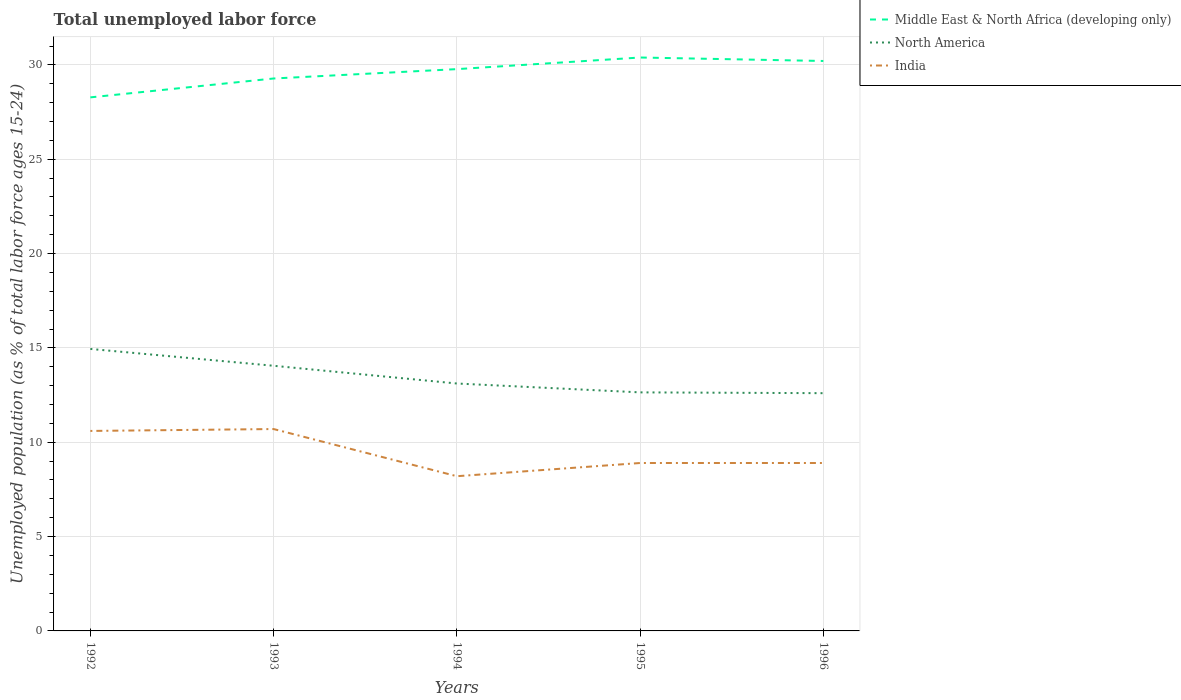Is the number of lines equal to the number of legend labels?
Your answer should be very brief. Yes. Across all years, what is the maximum percentage of unemployed population in in Middle East & North Africa (developing only)?
Ensure brevity in your answer.  28.28. What is the total percentage of unemployed population in in Middle East & North Africa (developing only) in the graph?
Offer a very short reply. -1.5. What is the difference between the highest and the second highest percentage of unemployed population in in Middle East & North Africa (developing only)?
Offer a terse response. 2.11. How many lines are there?
Offer a terse response. 3. How are the legend labels stacked?
Give a very brief answer. Vertical. What is the title of the graph?
Ensure brevity in your answer.  Total unemployed labor force. Does "Botswana" appear as one of the legend labels in the graph?
Provide a succinct answer. No. What is the label or title of the X-axis?
Your answer should be compact. Years. What is the label or title of the Y-axis?
Offer a very short reply. Unemployed population (as % of total labor force ages 15-24). What is the Unemployed population (as % of total labor force ages 15-24) of Middle East & North Africa (developing only) in 1992?
Your response must be concise. 28.28. What is the Unemployed population (as % of total labor force ages 15-24) in North America in 1992?
Keep it short and to the point. 14.95. What is the Unemployed population (as % of total labor force ages 15-24) in India in 1992?
Ensure brevity in your answer.  10.6. What is the Unemployed population (as % of total labor force ages 15-24) in Middle East & North Africa (developing only) in 1993?
Offer a very short reply. 29.28. What is the Unemployed population (as % of total labor force ages 15-24) of North America in 1993?
Your answer should be compact. 14.05. What is the Unemployed population (as % of total labor force ages 15-24) of India in 1993?
Keep it short and to the point. 10.7. What is the Unemployed population (as % of total labor force ages 15-24) in Middle East & North Africa (developing only) in 1994?
Offer a terse response. 29.78. What is the Unemployed population (as % of total labor force ages 15-24) of North America in 1994?
Make the answer very short. 13.11. What is the Unemployed population (as % of total labor force ages 15-24) of India in 1994?
Ensure brevity in your answer.  8.2. What is the Unemployed population (as % of total labor force ages 15-24) in Middle East & North Africa (developing only) in 1995?
Offer a very short reply. 30.39. What is the Unemployed population (as % of total labor force ages 15-24) of North America in 1995?
Give a very brief answer. 12.64. What is the Unemployed population (as % of total labor force ages 15-24) of India in 1995?
Keep it short and to the point. 8.9. What is the Unemployed population (as % of total labor force ages 15-24) of Middle East & North Africa (developing only) in 1996?
Ensure brevity in your answer.  30.21. What is the Unemployed population (as % of total labor force ages 15-24) in North America in 1996?
Ensure brevity in your answer.  12.6. What is the Unemployed population (as % of total labor force ages 15-24) in India in 1996?
Your answer should be compact. 8.9. Across all years, what is the maximum Unemployed population (as % of total labor force ages 15-24) of Middle East & North Africa (developing only)?
Keep it short and to the point. 30.39. Across all years, what is the maximum Unemployed population (as % of total labor force ages 15-24) of North America?
Your answer should be compact. 14.95. Across all years, what is the maximum Unemployed population (as % of total labor force ages 15-24) in India?
Your answer should be compact. 10.7. Across all years, what is the minimum Unemployed population (as % of total labor force ages 15-24) of Middle East & North Africa (developing only)?
Make the answer very short. 28.28. Across all years, what is the minimum Unemployed population (as % of total labor force ages 15-24) in North America?
Keep it short and to the point. 12.6. Across all years, what is the minimum Unemployed population (as % of total labor force ages 15-24) of India?
Provide a short and direct response. 8.2. What is the total Unemployed population (as % of total labor force ages 15-24) in Middle East & North Africa (developing only) in the graph?
Offer a very short reply. 147.94. What is the total Unemployed population (as % of total labor force ages 15-24) of North America in the graph?
Offer a terse response. 67.36. What is the total Unemployed population (as % of total labor force ages 15-24) in India in the graph?
Make the answer very short. 47.3. What is the difference between the Unemployed population (as % of total labor force ages 15-24) of Middle East & North Africa (developing only) in 1992 and that in 1993?
Provide a short and direct response. -1. What is the difference between the Unemployed population (as % of total labor force ages 15-24) of North America in 1992 and that in 1993?
Give a very brief answer. 0.89. What is the difference between the Unemployed population (as % of total labor force ages 15-24) of India in 1992 and that in 1993?
Ensure brevity in your answer.  -0.1. What is the difference between the Unemployed population (as % of total labor force ages 15-24) in Middle East & North Africa (developing only) in 1992 and that in 1994?
Provide a short and direct response. -1.5. What is the difference between the Unemployed population (as % of total labor force ages 15-24) in North America in 1992 and that in 1994?
Provide a succinct answer. 1.83. What is the difference between the Unemployed population (as % of total labor force ages 15-24) in Middle East & North Africa (developing only) in 1992 and that in 1995?
Ensure brevity in your answer.  -2.11. What is the difference between the Unemployed population (as % of total labor force ages 15-24) of North America in 1992 and that in 1995?
Your answer should be very brief. 2.3. What is the difference between the Unemployed population (as % of total labor force ages 15-24) in India in 1992 and that in 1995?
Your response must be concise. 1.7. What is the difference between the Unemployed population (as % of total labor force ages 15-24) in Middle East & North Africa (developing only) in 1992 and that in 1996?
Offer a very short reply. -1.93. What is the difference between the Unemployed population (as % of total labor force ages 15-24) in North America in 1992 and that in 1996?
Your answer should be compact. 2.34. What is the difference between the Unemployed population (as % of total labor force ages 15-24) of India in 1992 and that in 1996?
Offer a very short reply. 1.7. What is the difference between the Unemployed population (as % of total labor force ages 15-24) of Middle East & North Africa (developing only) in 1993 and that in 1994?
Give a very brief answer. -0.5. What is the difference between the Unemployed population (as % of total labor force ages 15-24) of North America in 1993 and that in 1994?
Offer a very short reply. 0.94. What is the difference between the Unemployed population (as % of total labor force ages 15-24) in India in 1993 and that in 1994?
Your answer should be very brief. 2.5. What is the difference between the Unemployed population (as % of total labor force ages 15-24) of Middle East & North Africa (developing only) in 1993 and that in 1995?
Provide a short and direct response. -1.11. What is the difference between the Unemployed population (as % of total labor force ages 15-24) of North America in 1993 and that in 1995?
Your answer should be very brief. 1.41. What is the difference between the Unemployed population (as % of total labor force ages 15-24) of India in 1993 and that in 1995?
Keep it short and to the point. 1.8. What is the difference between the Unemployed population (as % of total labor force ages 15-24) of Middle East & North Africa (developing only) in 1993 and that in 1996?
Keep it short and to the point. -0.93. What is the difference between the Unemployed population (as % of total labor force ages 15-24) of North America in 1993 and that in 1996?
Provide a succinct answer. 1.45. What is the difference between the Unemployed population (as % of total labor force ages 15-24) in Middle East & North Africa (developing only) in 1994 and that in 1995?
Ensure brevity in your answer.  -0.62. What is the difference between the Unemployed population (as % of total labor force ages 15-24) of North America in 1994 and that in 1995?
Ensure brevity in your answer.  0.47. What is the difference between the Unemployed population (as % of total labor force ages 15-24) in Middle East & North Africa (developing only) in 1994 and that in 1996?
Your answer should be very brief. -0.43. What is the difference between the Unemployed population (as % of total labor force ages 15-24) of North America in 1994 and that in 1996?
Your answer should be compact. 0.51. What is the difference between the Unemployed population (as % of total labor force ages 15-24) in Middle East & North Africa (developing only) in 1995 and that in 1996?
Your answer should be very brief. 0.18. What is the difference between the Unemployed population (as % of total labor force ages 15-24) of North America in 1995 and that in 1996?
Give a very brief answer. 0.04. What is the difference between the Unemployed population (as % of total labor force ages 15-24) in Middle East & North Africa (developing only) in 1992 and the Unemployed population (as % of total labor force ages 15-24) in North America in 1993?
Give a very brief answer. 14.23. What is the difference between the Unemployed population (as % of total labor force ages 15-24) in Middle East & North Africa (developing only) in 1992 and the Unemployed population (as % of total labor force ages 15-24) in India in 1993?
Offer a very short reply. 17.58. What is the difference between the Unemployed population (as % of total labor force ages 15-24) in North America in 1992 and the Unemployed population (as % of total labor force ages 15-24) in India in 1993?
Offer a very short reply. 4.25. What is the difference between the Unemployed population (as % of total labor force ages 15-24) in Middle East & North Africa (developing only) in 1992 and the Unemployed population (as % of total labor force ages 15-24) in North America in 1994?
Provide a short and direct response. 15.17. What is the difference between the Unemployed population (as % of total labor force ages 15-24) of Middle East & North Africa (developing only) in 1992 and the Unemployed population (as % of total labor force ages 15-24) of India in 1994?
Keep it short and to the point. 20.08. What is the difference between the Unemployed population (as % of total labor force ages 15-24) of North America in 1992 and the Unemployed population (as % of total labor force ages 15-24) of India in 1994?
Give a very brief answer. 6.75. What is the difference between the Unemployed population (as % of total labor force ages 15-24) of Middle East & North Africa (developing only) in 1992 and the Unemployed population (as % of total labor force ages 15-24) of North America in 1995?
Offer a very short reply. 15.64. What is the difference between the Unemployed population (as % of total labor force ages 15-24) in Middle East & North Africa (developing only) in 1992 and the Unemployed population (as % of total labor force ages 15-24) in India in 1995?
Give a very brief answer. 19.38. What is the difference between the Unemployed population (as % of total labor force ages 15-24) in North America in 1992 and the Unemployed population (as % of total labor force ages 15-24) in India in 1995?
Make the answer very short. 6.05. What is the difference between the Unemployed population (as % of total labor force ages 15-24) of Middle East & North Africa (developing only) in 1992 and the Unemployed population (as % of total labor force ages 15-24) of North America in 1996?
Offer a very short reply. 15.68. What is the difference between the Unemployed population (as % of total labor force ages 15-24) of Middle East & North Africa (developing only) in 1992 and the Unemployed population (as % of total labor force ages 15-24) of India in 1996?
Offer a very short reply. 19.38. What is the difference between the Unemployed population (as % of total labor force ages 15-24) of North America in 1992 and the Unemployed population (as % of total labor force ages 15-24) of India in 1996?
Make the answer very short. 6.05. What is the difference between the Unemployed population (as % of total labor force ages 15-24) of Middle East & North Africa (developing only) in 1993 and the Unemployed population (as % of total labor force ages 15-24) of North America in 1994?
Provide a succinct answer. 16.17. What is the difference between the Unemployed population (as % of total labor force ages 15-24) of Middle East & North Africa (developing only) in 1993 and the Unemployed population (as % of total labor force ages 15-24) of India in 1994?
Your answer should be very brief. 21.08. What is the difference between the Unemployed population (as % of total labor force ages 15-24) in North America in 1993 and the Unemployed population (as % of total labor force ages 15-24) in India in 1994?
Your answer should be compact. 5.85. What is the difference between the Unemployed population (as % of total labor force ages 15-24) of Middle East & North Africa (developing only) in 1993 and the Unemployed population (as % of total labor force ages 15-24) of North America in 1995?
Your answer should be compact. 16.64. What is the difference between the Unemployed population (as % of total labor force ages 15-24) in Middle East & North Africa (developing only) in 1993 and the Unemployed population (as % of total labor force ages 15-24) in India in 1995?
Make the answer very short. 20.38. What is the difference between the Unemployed population (as % of total labor force ages 15-24) in North America in 1993 and the Unemployed population (as % of total labor force ages 15-24) in India in 1995?
Your answer should be compact. 5.15. What is the difference between the Unemployed population (as % of total labor force ages 15-24) of Middle East & North Africa (developing only) in 1993 and the Unemployed population (as % of total labor force ages 15-24) of North America in 1996?
Provide a short and direct response. 16.68. What is the difference between the Unemployed population (as % of total labor force ages 15-24) of Middle East & North Africa (developing only) in 1993 and the Unemployed population (as % of total labor force ages 15-24) of India in 1996?
Keep it short and to the point. 20.38. What is the difference between the Unemployed population (as % of total labor force ages 15-24) in North America in 1993 and the Unemployed population (as % of total labor force ages 15-24) in India in 1996?
Offer a very short reply. 5.15. What is the difference between the Unemployed population (as % of total labor force ages 15-24) in Middle East & North Africa (developing only) in 1994 and the Unemployed population (as % of total labor force ages 15-24) in North America in 1995?
Offer a very short reply. 17.13. What is the difference between the Unemployed population (as % of total labor force ages 15-24) of Middle East & North Africa (developing only) in 1994 and the Unemployed population (as % of total labor force ages 15-24) of India in 1995?
Give a very brief answer. 20.88. What is the difference between the Unemployed population (as % of total labor force ages 15-24) in North America in 1994 and the Unemployed population (as % of total labor force ages 15-24) in India in 1995?
Your response must be concise. 4.21. What is the difference between the Unemployed population (as % of total labor force ages 15-24) in Middle East & North Africa (developing only) in 1994 and the Unemployed population (as % of total labor force ages 15-24) in North America in 1996?
Your response must be concise. 17.18. What is the difference between the Unemployed population (as % of total labor force ages 15-24) of Middle East & North Africa (developing only) in 1994 and the Unemployed population (as % of total labor force ages 15-24) of India in 1996?
Your answer should be very brief. 20.88. What is the difference between the Unemployed population (as % of total labor force ages 15-24) in North America in 1994 and the Unemployed population (as % of total labor force ages 15-24) in India in 1996?
Your answer should be very brief. 4.21. What is the difference between the Unemployed population (as % of total labor force ages 15-24) of Middle East & North Africa (developing only) in 1995 and the Unemployed population (as % of total labor force ages 15-24) of North America in 1996?
Your answer should be compact. 17.79. What is the difference between the Unemployed population (as % of total labor force ages 15-24) in Middle East & North Africa (developing only) in 1995 and the Unemployed population (as % of total labor force ages 15-24) in India in 1996?
Keep it short and to the point. 21.49. What is the difference between the Unemployed population (as % of total labor force ages 15-24) of North America in 1995 and the Unemployed population (as % of total labor force ages 15-24) of India in 1996?
Your answer should be compact. 3.74. What is the average Unemployed population (as % of total labor force ages 15-24) in Middle East & North Africa (developing only) per year?
Give a very brief answer. 29.59. What is the average Unemployed population (as % of total labor force ages 15-24) of North America per year?
Ensure brevity in your answer.  13.47. What is the average Unemployed population (as % of total labor force ages 15-24) of India per year?
Provide a succinct answer. 9.46. In the year 1992, what is the difference between the Unemployed population (as % of total labor force ages 15-24) of Middle East & North Africa (developing only) and Unemployed population (as % of total labor force ages 15-24) of North America?
Keep it short and to the point. 13.33. In the year 1992, what is the difference between the Unemployed population (as % of total labor force ages 15-24) of Middle East & North Africa (developing only) and Unemployed population (as % of total labor force ages 15-24) of India?
Your response must be concise. 17.68. In the year 1992, what is the difference between the Unemployed population (as % of total labor force ages 15-24) of North America and Unemployed population (as % of total labor force ages 15-24) of India?
Provide a succinct answer. 4.35. In the year 1993, what is the difference between the Unemployed population (as % of total labor force ages 15-24) of Middle East & North Africa (developing only) and Unemployed population (as % of total labor force ages 15-24) of North America?
Your answer should be compact. 15.23. In the year 1993, what is the difference between the Unemployed population (as % of total labor force ages 15-24) in Middle East & North Africa (developing only) and Unemployed population (as % of total labor force ages 15-24) in India?
Provide a succinct answer. 18.58. In the year 1993, what is the difference between the Unemployed population (as % of total labor force ages 15-24) of North America and Unemployed population (as % of total labor force ages 15-24) of India?
Offer a terse response. 3.35. In the year 1994, what is the difference between the Unemployed population (as % of total labor force ages 15-24) in Middle East & North Africa (developing only) and Unemployed population (as % of total labor force ages 15-24) in North America?
Provide a short and direct response. 16.66. In the year 1994, what is the difference between the Unemployed population (as % of total labor force ages 15-24) in Middle East & North Africa (developing only) and Unemployed population (as % of total labor force ages 15-24) in India?
Provide a succinct answer. 21.58. In the year 1994, what is the difference between the Unemployed population (as % of total labor force ages 15-24) of North America and Unemployed population (as % of total labor force ages 15-24) of India?
Make the answer very short. 4.91. In the year 1995, what is the difference between the Unemployed population (as % of total labor force ages 15-24) of Middle East & North Africa (developing only) and Unemployed population (as % of total labor force ages 15-24) of North America?
Keep it short and to the point. 17.75. In the year 1995, what is the difference between the Unemployed population (as % of total labor force ages 15-24) in Middle East & North Africa (developing only) and Unemployed population (as % of total labor force ages 15-24) in India?
Keep it short and to the point. 21.49. In the year 1995, what is the difference between the Unemployed population (as % of total labor force ages 15-24) of North America and Unemployed population (as % of total labor force ages 15-24) of India?
Give a very brief answer. 3.74. In the year 1996, what is the difference between the Unemployed population (as % of total labor force ages 15-24) of Middle East & North Africa (developing only) and Unemployed population (as % of total labor force ages 15-24) of North America?
Make the answer very short. 17.61. In the year 1996, what is the difference between the Unemployed population (as % of total labor force ages 15-24) in Middle East & North Africa (developing only) and Unemployed population (as % of total labor force ages 15-24) in India?
Your answer should be compact. 21.31. In the year 1996, what is the difference between the Unemployed population (as % of total labor force ages 15-24) in North America and Unemployed population (as % of total labor force ages 15-24) in India?
Offer a terse response. 3.7. What is the ratio of the Unemployed population (as % of total labor force ages 15-24) in Middle East & North Africa (developing only) in 1992 to that in 1993?
Your response must be concise. 0.97. What is the ratio of the Unemployed population (as % of total labor force ages 15-24) in North America in 1992 to that in 1993?
Offer a terse response. 1.06. What is the ratio of the Unemployed population (as % of total labor force ages 15-24) in Middle East & North Africa (developing only) in 1992 to that in 1994?
Keep it short and to the point. 0.95. What is the ratio of the Unemployed population (as % of total labor force ages 15-24) in North America in 1992 to that in 1994?
Ensure brevity in your answer.  1.14. What is the ratio of the Unemployed population (as % of total labor force ages 15-24) of India in 1992 to that in 1994?
Provide a short and direct response. 1.29. What is the ratio of the Unemployed population (as % of total labor force ages 15-24) in Middle East & North Africa (developing only) in 1992 to that in 1995?
Provide a succinct answer. 0.93. What is the ratio of the Unemployed population (as % of total labor force ages 15-24) of North America in 1992 to that in 1995?
Provide a short and direct response. 1.18. What is the ratio of the Unemployed population (as % of total labor force ages 15-24) in India in 1992 to that in 1995?
Offer a terse response. 1.19. What is the ratio of the Unemployed population (as % of total labor force ages 15-24) of Middle East & North Africa (developing only) in 1992 to that in 1996?
Give a very brief answer. 0.94. What is the ratio of the Unemployed population (as % of total labor force ages 15-24) in North America in 1992 to that in 1996?
Offer a terse response. 1.19. What is the ratio of the Unemployed population (as % of total labor force ages 15-24) of India in 1992 to that in 1996?
Offer a very short reply. 1.19. What is the ratio of the Unemployed population (as % of total labor force ages 15-24) of Middle East & North Africa (developing only) in 1993 to that in 1994?
Offer a terse response. 0.98. What is the ratio of the Unemployed population (as % of total labor force ages 15-24) in North America in 1993 to that in 1994?
Make the answer very short. 1.07. What is the ratio of the Unemployed population (as % of total labor force ages 15-24) of India in 1993 to that in 1994?
Your answer should be very brief. 1.3. What is the ratio of the Unemployed population (as % of total labor force ages 15-24) in Middle East & North Africa (developing only) in 1993 to that in 1995?
Your response must be concise. 0.96. What is the ratio of the Unemployed population (as % of total labor force ages 15-24) in North America in 1993 to that in 1995?
Provide a succinct answer. 1.11. What is the ratio of the Unemployed population (as % of total labor force ages 15-24) in India in 1993 to that in 1995?
Your response must be concise. 1.2. What is the ratio of the Unemployed population (as % of total labor force ages 15-24) of Middle East & North Africa (developing only) in 1993 to that in 1996?
Offer a terse response. 0.97. What is the ratio of the Unemployed population (as % of total labor force ages 15-24) of North America in 1993 to that in 1996?
Offer a terse response. 1.12. What is the ratio of the Unemployed population (as % of total labor force ages 15-24) of India in 1993 to that in 1996?
Ensure brevity in your answer.  1.2. What is the ratio of the Unemployed population (as % of total labor force ages 15-24) of Middle East & North Africa (developing only) in 1994 to that in 1995?
Provide a succinct answer. 0.98. What is the ratio of the Unemployed population (as % of total labor force ages 15-24) in North America in 1994 to that in 1995?
Offer a very short reply. 1.04. What is the ratio of the Unemployed population (as % of total labor force ages 15-24) in India in 1994 to that in 1995?
Offer a very short reply. 0.92. What is the ratio of the Unemployed population (as % of total labor force ages 15-24) of Middle East & North Africa (developing only) in 1994 to that in 1996?
Offer a terse response. 0.99. What is the ratio of the Unemployed population (as % of total labor force ages 15-24) in North America in 1994 to that in 1996?
Ensure brevity in your answer.  1.04. What is the ratio of the Unemployed population (as % of total labor force ages 15-24) of India in 1994 to that in 1996?
Your answer should be compact. 0.92. What is the ratio of the Unemployed population (as % of total labor force ages 15-24) in Middle East & North Africa (developing only) in 1995 to that in 1996?
Provide a succinct answer. 1.01. What is the ratio of the Unemployed population (as % of total labor force ages 15-24) of India in 1995 to that in 1996?
Offer a very short reply. 1. What is the difference between the highest and the second highest Unemployed population (as % of total labor force ages 15-24) of Middle East & North Africa (developing only)?
Provide a succinct answer. 0.18. What is the difference between the highest and the second highest Unemployed population (as % of total labor force ages 15-24) of North America?
Your answer should be very brief. 0.89. What is the difference between the highest and the lowest Unemployed population (as % of total labor force ages 15-24) of Middle East & North Africa (developing only)?
Ensure brevity in your answer.  2.11. What is the difference between the highest and the lowest Unemployed population (as % of total labor force ages 15-24) of North America?
Offer a terse response. 2.34. 